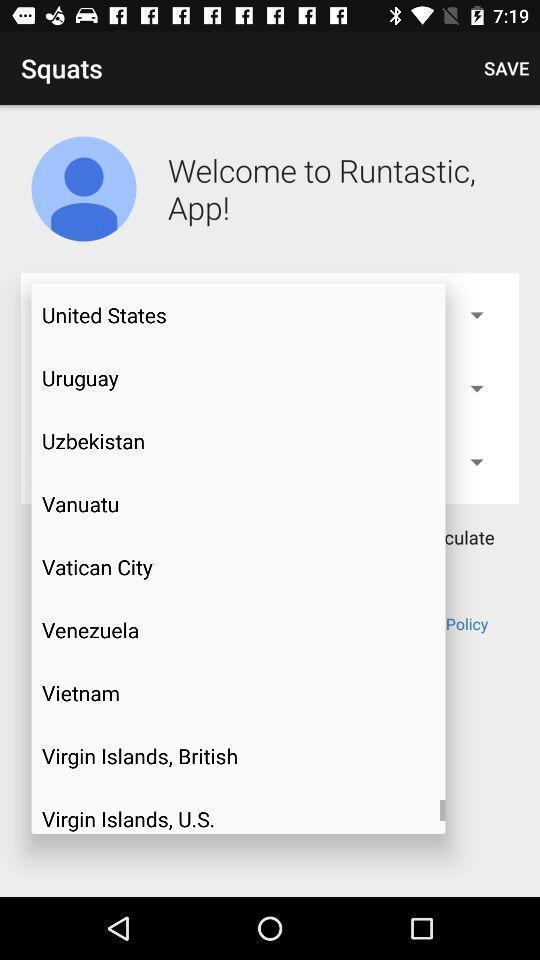Explain the elements present in this screenshot. Pop-up showing various cities. 